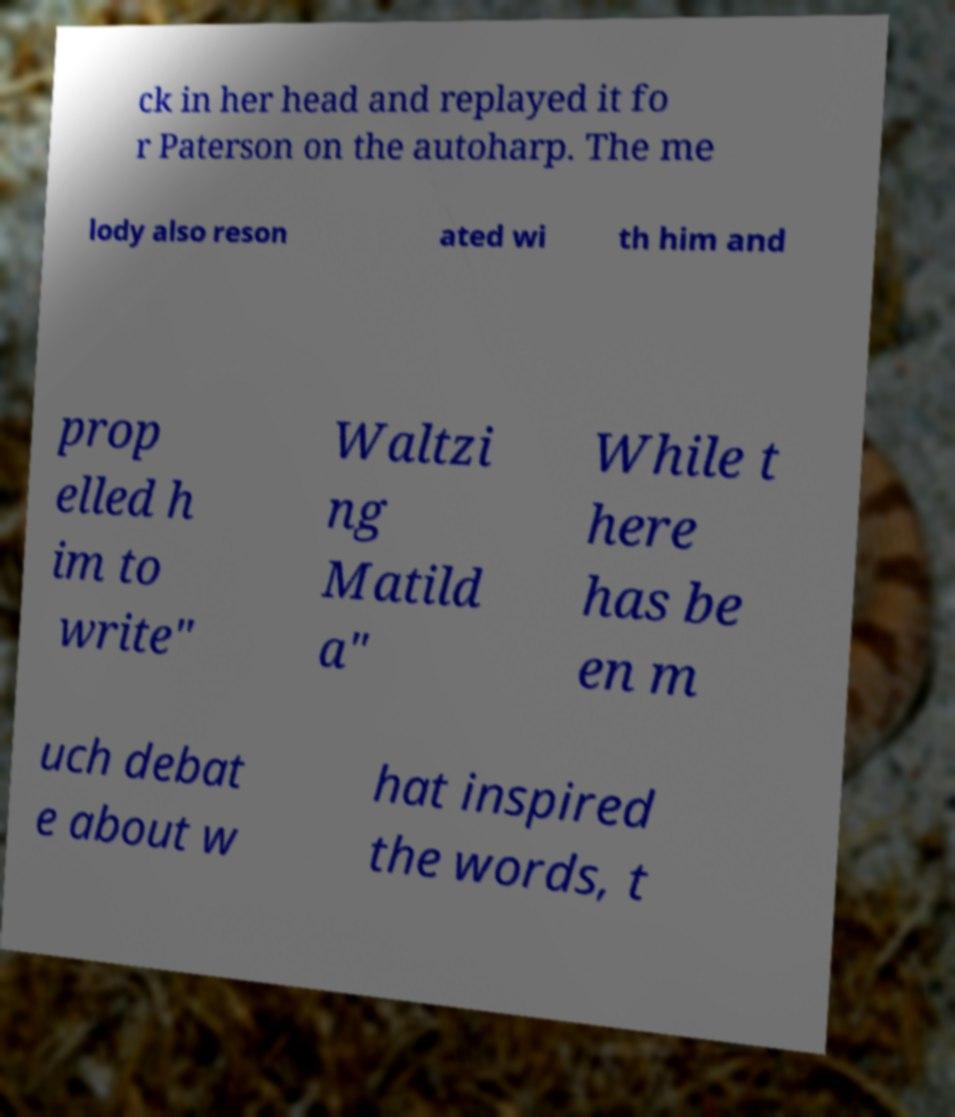Could you extract and type out the text from this image? ck in her head and replayed it fo r Paterson on the autoharp. The me lody also reson ated wi th him and prop elled h im to write" Waltzi ng Matild a" While t here has be en m uch debat e about w hat inspired the words, t 